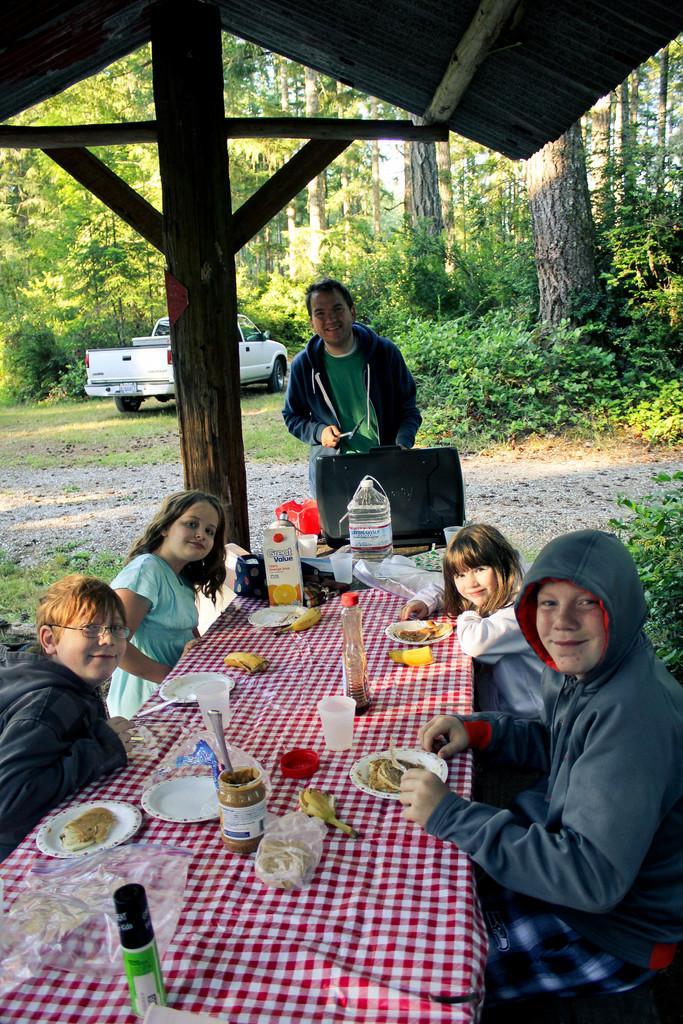Could you give a brief overview of what you see in this image? There are few people sitting on the chair at the table and a man standing in the middle. On the table we can see food items,plates,glasses. In the background there is a vehicle and trees, 